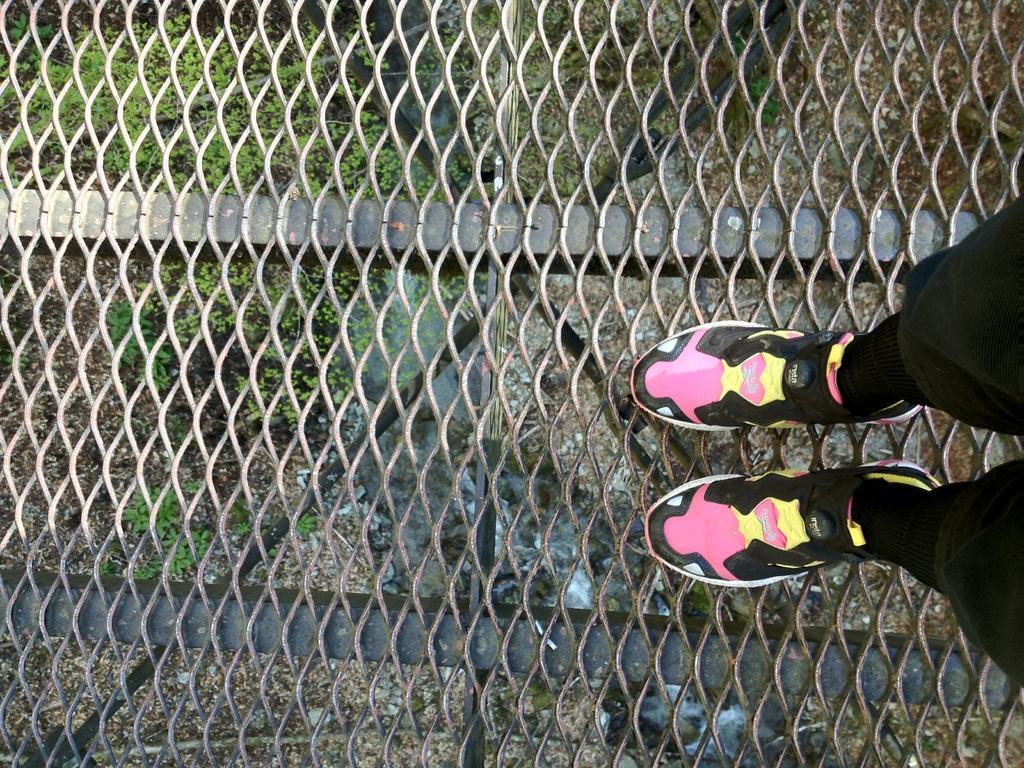Can you describe this image briefly? In a given image I can see a fence, human legs and grass. 